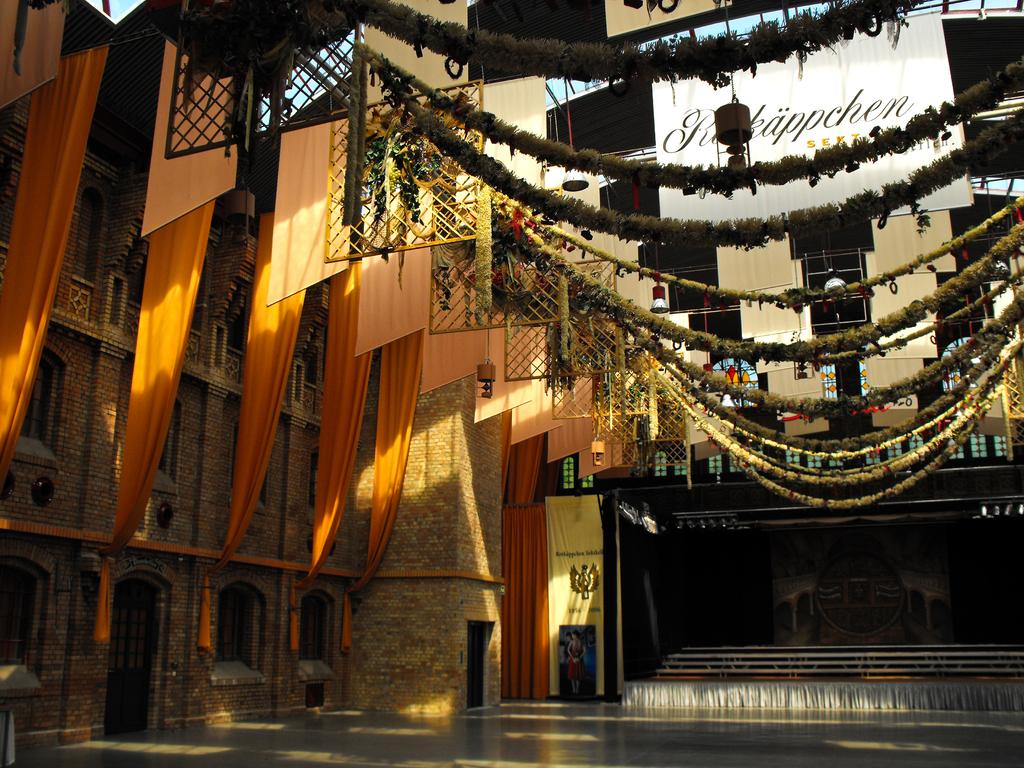What type of structure is visible in the image? There is a building in the image. What is the purpose of the stage in the image? The stage is likely used for performances or events. What type of decoration can be seen in the image? There is decoration with flower garlands in the image. What type of items are present in the image? There are clothes present in the image. How many mice are hiding behind the clothes in the image? There are no mice present in the image; it only features a building, a stage, decoration with flower garlands, and clothes. 